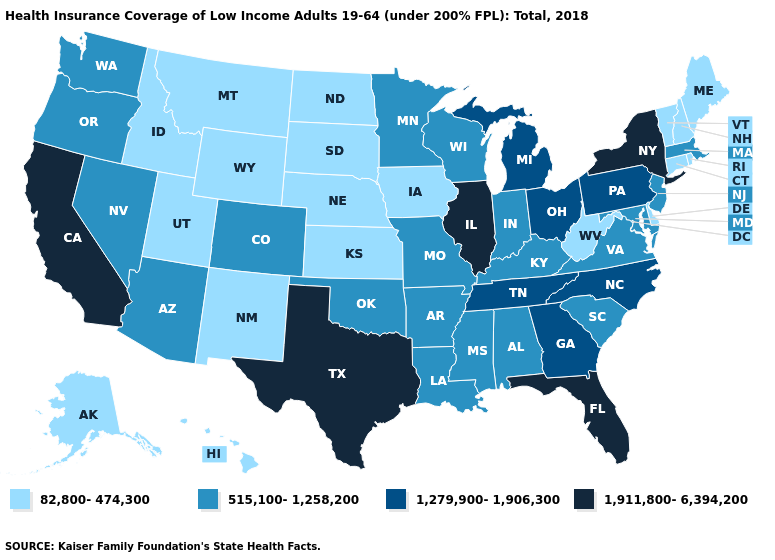Does Colorado have a lower value than Illinois?
Keep it brief. Yes. Does the first symbol in the legend represent the smallest category?
Write a very short answer. Yes. Name the states that have a value in the range 82,800-474,300?
Give a very brief answer. Alaska, Connecticut, Delaware, Hawaii, Idaho, Iowa, Kansas, Maine, Montana, Nebraska, New Hampshire, New Mexico, North Dakota, Rhode Island, South Dakota, Utah, Vermont, West Virginia, Wyoming. Among the states that border Alabama , which have the lowest value?
Be succinct. Mississippi. Does Oklahoma have the highest value in the USA?
Concise answer only. No. Which states have the lowest value in the West?
Be succinct. Alaska, Hawaii, Idaho, Montana, New Mexico, Utah, Wyoming. Is the legend a continuous bar?
Answer briefly. No. What is the value of South Dakota?
Short answer required. 82,800-474,300. Name the states that have a value in the range 82,800-474,300?
Keep it brief. Alaska, Connecticut, Delaware, Hawaii, Idaho, Iowa, Kansas, Maine, Montana, Nebraska, New Hampshire, New Mexico, North Dakota, Rhode Island, South Dakota, Utah, Vermont, West Virginia, Wyoming. What is the value of Nebraska?
Short answer required. 82,800-474,300. Does New Mexico have the highest value in the USA?
Give a very brief answer. No. Name the states that have a value in the range 82,800-474,300?
Concise answer only. Alaska, Connecticut, Delaware, Hawaii, Idaho, Iowa, Kansas, Maine, Montana, Nebraska, New Hampshire, New Mexico, North Dakota, Rhode Island, South Dakota, Utah, Vermont, West Virginia, Wyoming. Does New York have the highest value in the Northeast?
Answer briefly. Yes. Does Wisconsin have the same value as Florida?
Quick response, please. No. Name the states that have a value in the range 1,279,900-1,906,300?
Be succinct. Georgia, Michigan, North Carolina, Ohio, Pennsylvania, Tennessee. 